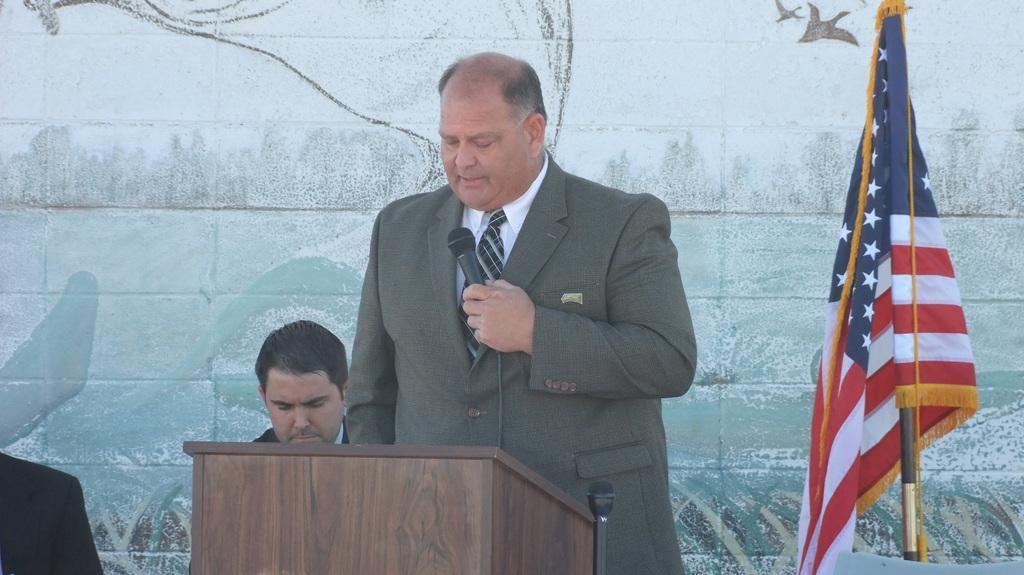How would you summarize this image in a sentence or two? In this image we can see few people. A person standing near the podium and speaking into a mic. There is a flag at the right side of the image. We can see the painting on the wall. 